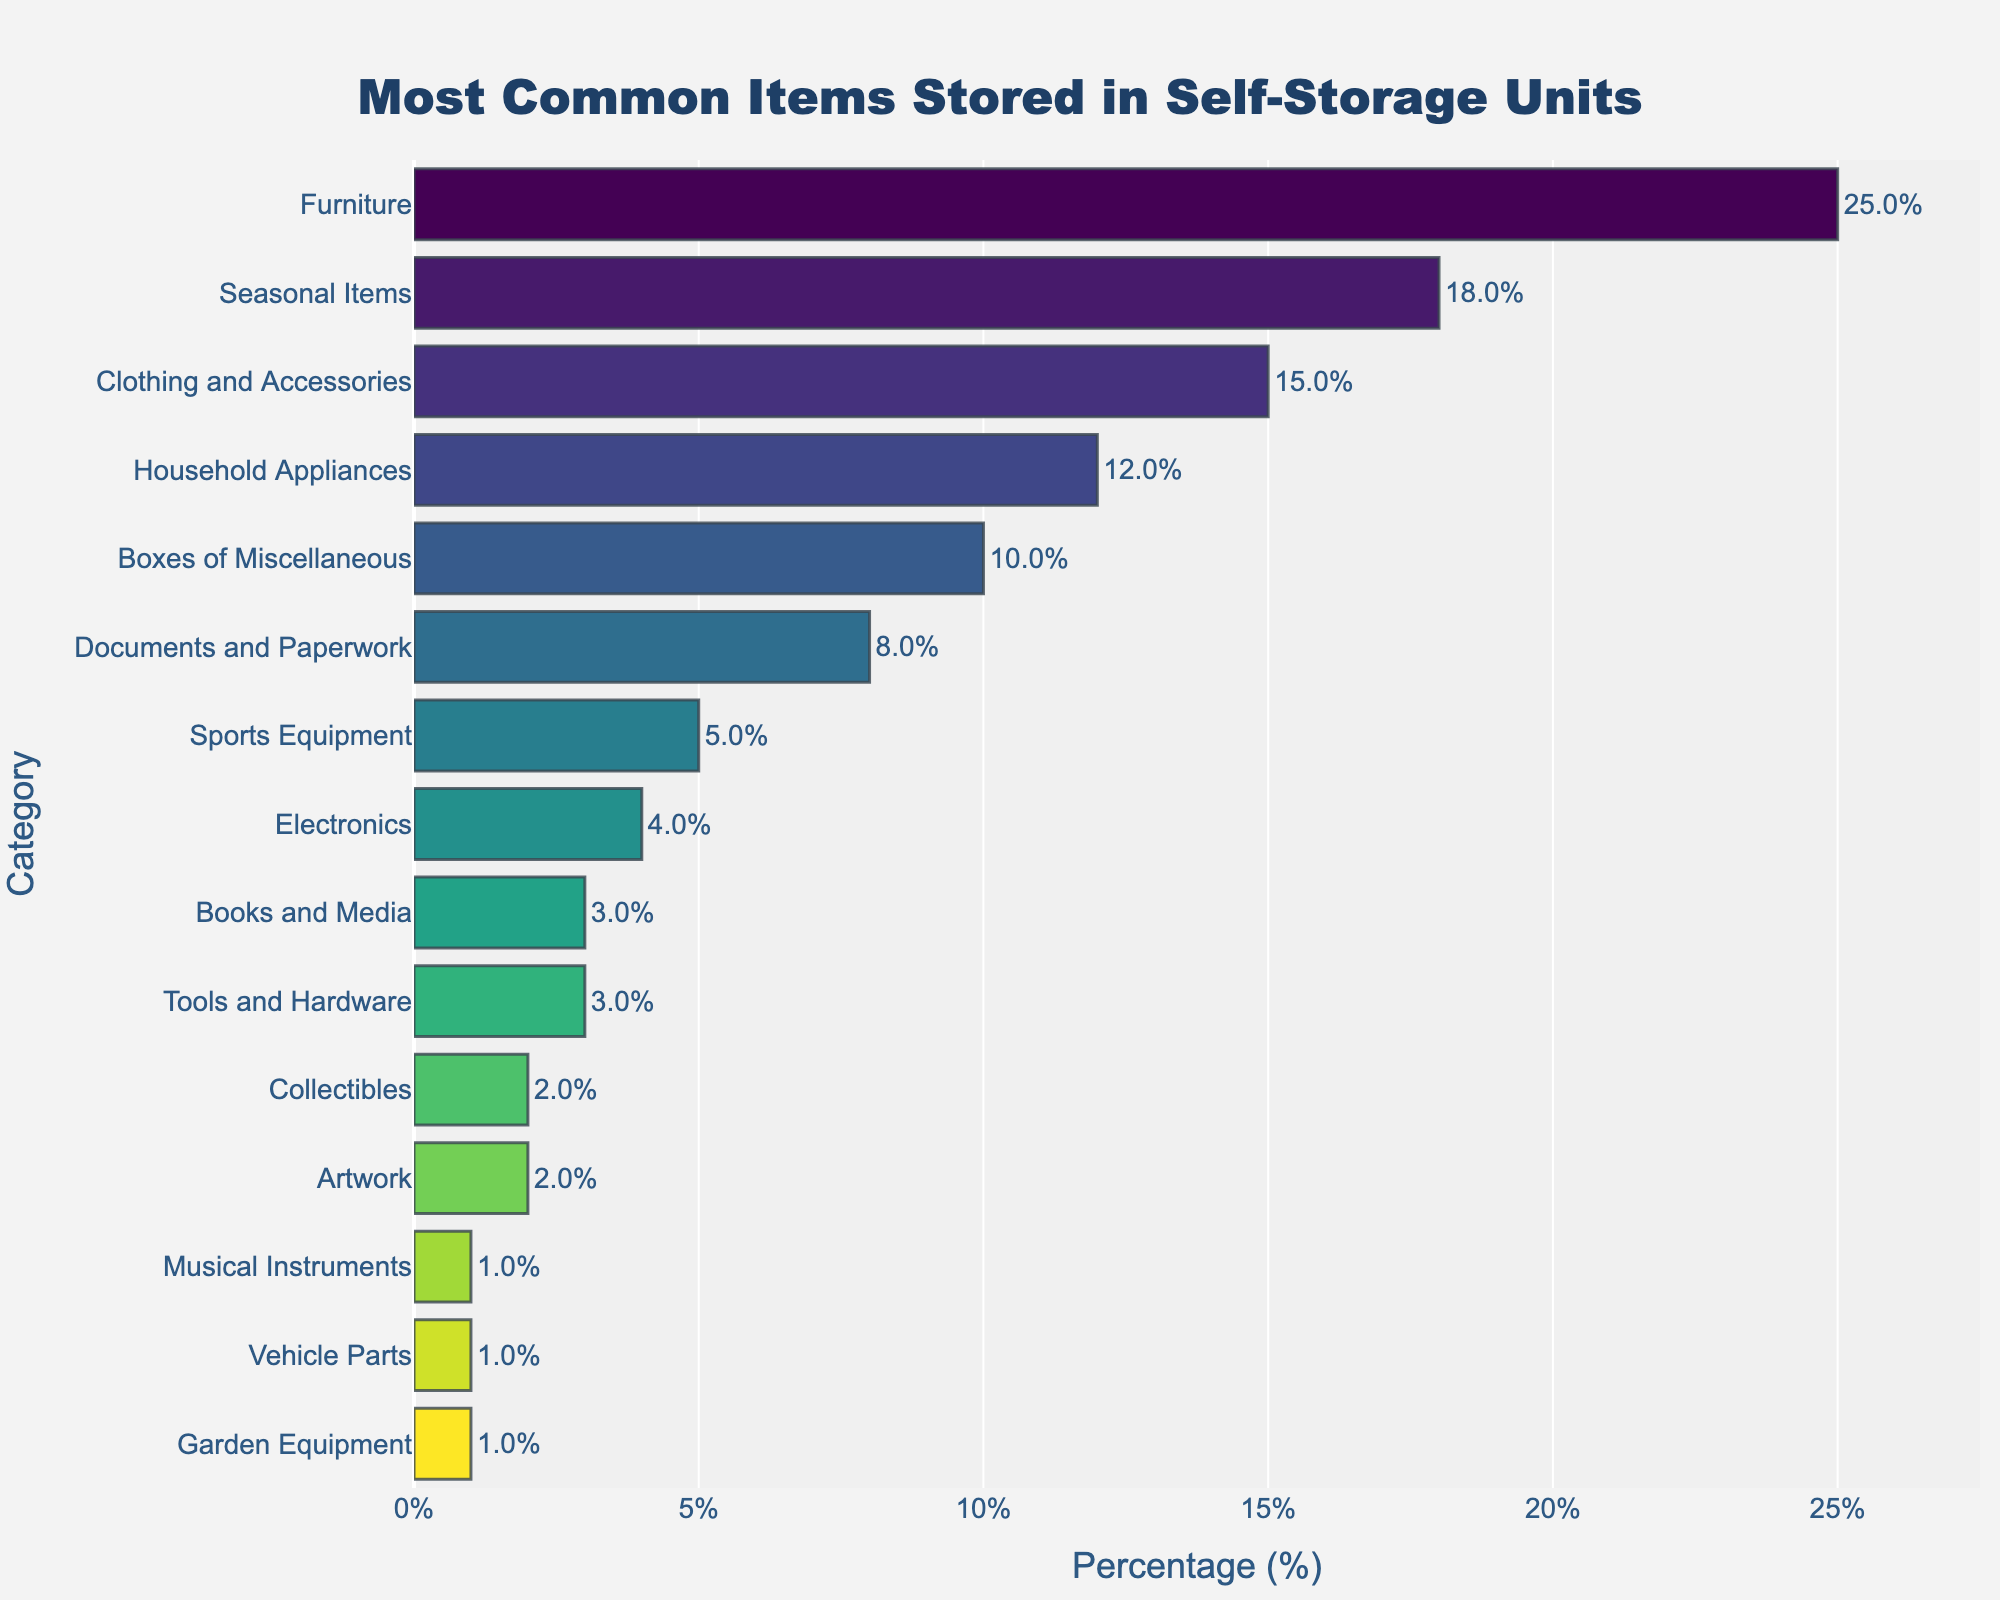What is the most common item stored in self-storage units? The bar chart shows that the category with the highest percentage is "Furniture" at 25%. Therefore, the most common item stored in self-storage units is Furniture.
Answer: Furniture Which is stored more frequently, Clothing and Accessories or Sports Equipment? The bar chart indicates that Clothing and Accessories have a percentage of 15%, whereas Sports Equipment has a percentage of 5%. Therefore, Clothing and Accessories are stored more frequently.
Answer: Clothing and Accessories What is the combined percentage of Household Appliances and Boxes of Miscellaneous? The percentage of Household Appliances is 12%, and the Boxes of Miscellaneous is 10%. Adding these together gives 12% + 10% = 22%.
Answer: 22% Which category is stored less frequently, Vehicle Parts or Artwork? According to the bar chart, both Vehicle Parts and Artwork have the same percentage of 1%. Therefore, neither is stored less or more frequently than the other.
Answer: They are the same Which item has a lower stored percentage, Books and Media or Tools and Hardware? From the bar chart, Books and Media have a percentage of 3%, while Tools and Hardware also have a percentage of 3%. Therefore, they have the same stored percentage.
Answer: They are the same How many categories have a percentage of 5% or less? By scanning the bar chart, the categories with percentages of 5% or less are Sports Equipment (5%), Electronics (4%), Books and Media (3%), Tools and Hardware (3%), Collectibles (2%), Artwork (2%), Musical Instruments (1%), Vehicle Parts (1%), and Garden Equipment (1%). Counting these, there are 9 categories in total.
Answer: 9 What is the visual difference between the category with the highest percentage and the category with the lowest percentage? The category with the highest percentage is Furniture at 25%, whereas the lowest percentages are shared by three categories: Musical Instruments, Vehicle Parts, and Garden Equipment, each at 1%. Visually, the bar for Furniture is much longer than those for the lowest percentages.
Answer: Furniture bar is much longer than others Which two categories together make up 23% of the stored items? By examining the percentages, Seasonal Items at 18% and Documents and Paperwork at 8% together make 23%. Verifying this with other combinations doesn't yield the same result. Therefore, the two categories are Seasonal Items and Documents and Paperwork.
Answer: Seasonal Items and Documents and Paperwork What is the difference in percentage points between Electronics and Household Appliances? According to the bar chart, Household Appliances account for 12% while Electronics account for 4%. The difference is calculated as 12% - 4% = 8%.
Answer: 8% What is the range of the percentages shown in the bar chart? To find the range, subtract the smallest value from the largest. The highest percentage is 25% (Furniture), and the lowest is 1% (Musical Instruments, Vehicle Parts, and Garden Equipment). Thus, the range is 25% - 1% = 24%.
Answer: 24% 